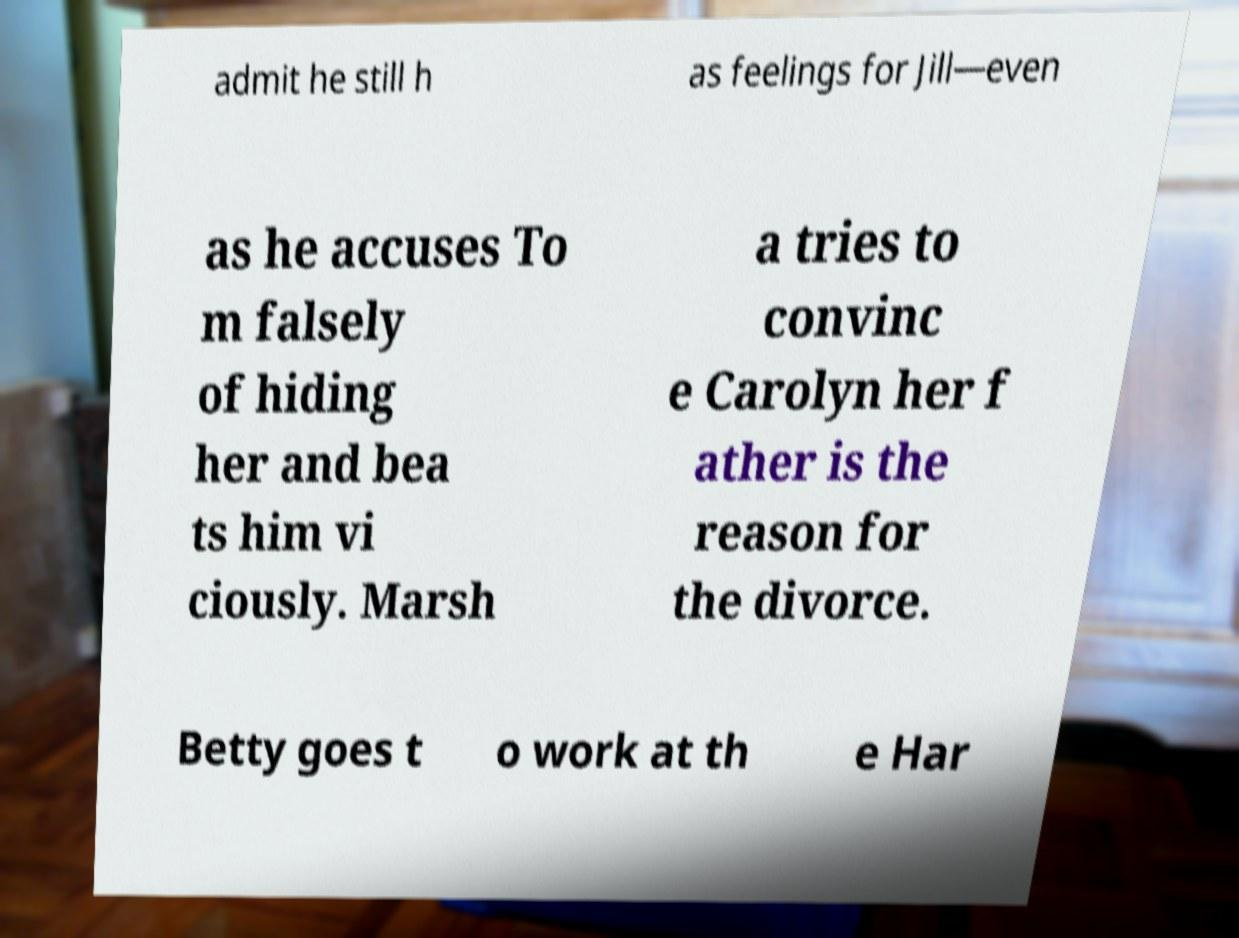Please identify and transcribe the text found in this image. admit he still h as feelings for Jill—even as he accuses To m falsely of hiding her and bea ts him vi ciously. Marsh a tries to convinc e Carolyn her f ather is the reason for the divorce. Betty goes t o work at th e Har 